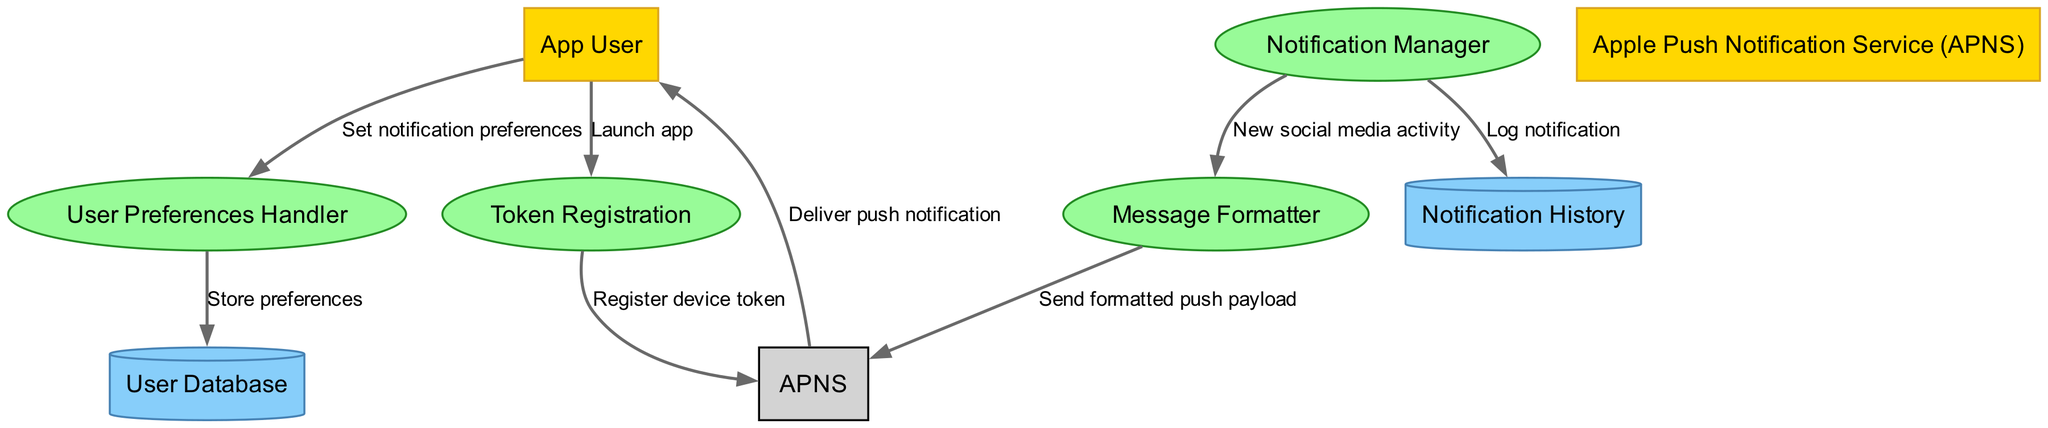What are the external entities in this diagram? The diagram identifies two external entities: "App User" and "Apple Push Notification Service (APNS)". These entities interact with the processes in the diagram to send and receive notifications.
Answer: App User, Apple Push Notification Service (APNS) How many processes are depicted in the diagram? The diagram depicts four processes: "Notification Manager", "User Preferences Handler", "Token Registration", and "Message Formatter". By counting these processes, we find a total of four.
Answer: 4 What data flow occurs when the app user sets notification preferences? The data flow where the "App User" sets notification preferences occurs between the "App User" and the "User Preferences Handler", labeled as "Set notification preferences". This indicates a direct interaction where user preferences are being communicated.
Answer: Set notification preferences Which process registers the device token with APNS? The "Token Registration" process is responsible for registering the device token with the "Apple Push Notification Service (APNS)". This is indicated by the data flow from "Token Registration" to "APNS" labeled "Register device token".
Answer: Token Registration What happens after the Notification Manager receives new social media activity? After "Notification Manager" receives new social media activity, it sends this information to "Message Formatter", as indicated by the data flow labeled "New social media activity". The formatter then prepares the message to be sent to APNS.
Answer: Send formatted push payload How does the Notification History interact with the Notification Manager? The "Notification History" interacts with the "Notification Manager" by receiving logs of notifications that are processed. This flow is labeled as "Log notification", indicating that notifications are stored for future reference.
Answer: Log notification What is delivered to the App User from APNS? The "Apple Push Notification Service (APNS)" delivers "push notification" to the "App User". This delivery is represented as a flow from APNS to App User labeled "Deliver push notification".
Answer: Deliver push notification Which data store contains user preferences? The "User Database" contains user preferences that are stored after being set by the "User Preferences Handler". This is represented in the flow labeled "Store preferences".
Answer: User Database What is the purpose of the Message Formatter process? The purpose of the "Message Formatter" process is to send a formatted push payload to the APNS. This is indicated by the flow labeled "Send formatted push payload". The formatter ensures that notifications are correctly structured for delivery.
Answer: Send formatted push payload 